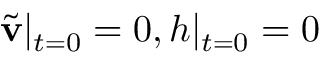<formula> <loc_0><loc_0><loc_500><loc_500>\tilde { v } | _ { t = 0 } = 0 , h | _ { t = 0 } = 0</formula> 